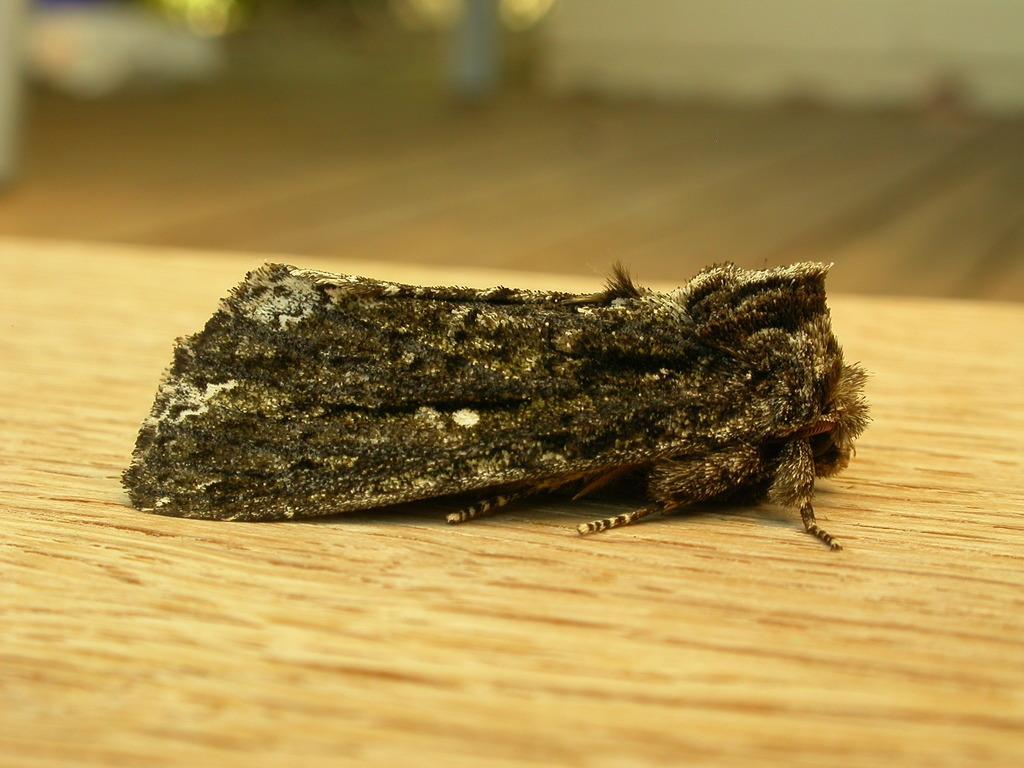Can you describe this image briefly? In the image we can see an insect on the wooden surface and the background is blurred. 